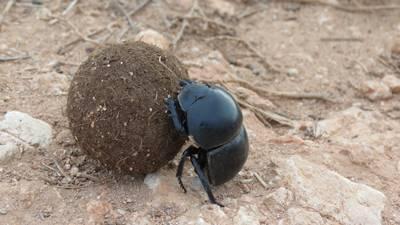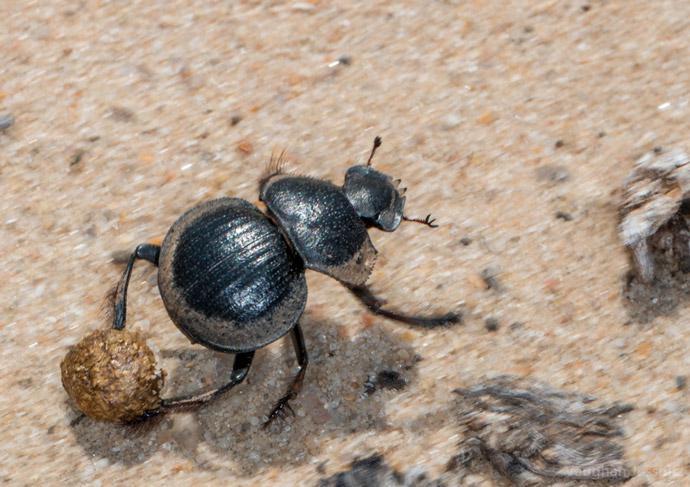The first image is the image on the left, the second image is the image on the right. Evaluate the accuracy of this statement regarding the images: "The left image contains two beetles.". Is it true? Answer yes or no. No. The first image is the image on the left, the second image is the image on the right. Evaluate the accuracy of this statement regarding the images: "There are two beetles on the clod of dirt in the image on the left.". Is it true? Answer yes or no. No. 